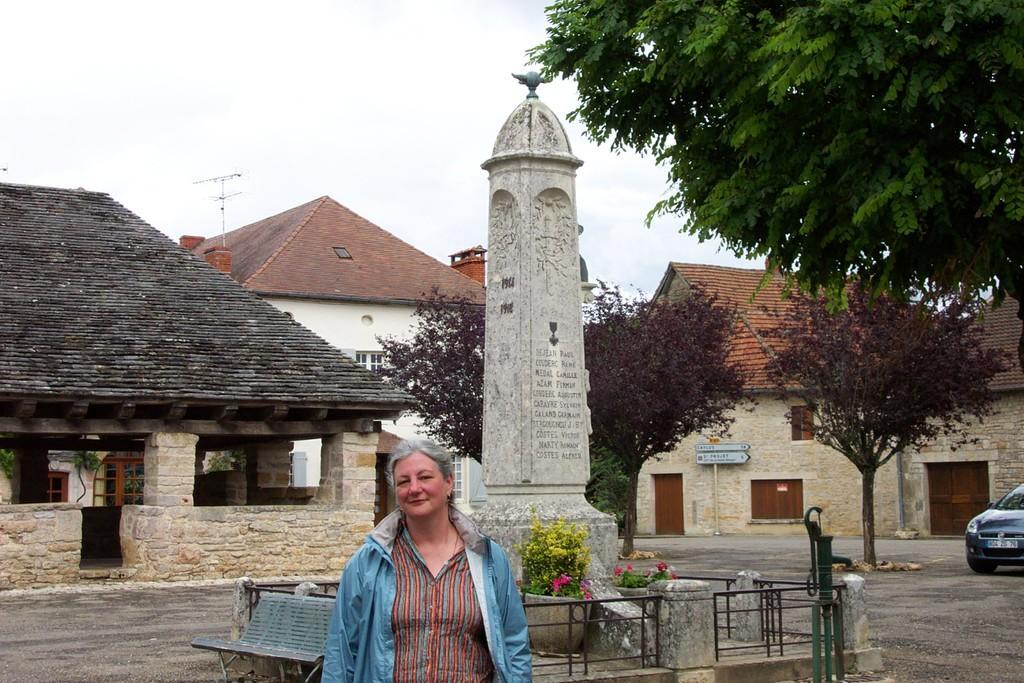Describe this image in one or two sentences. In the foreground of the picture there is a woman standing. In the center picture there is a sculpture and there are plants, flowers, railing, pump and a bench. In the background there are houses, trees, car and a road. Sky is cloudy. 